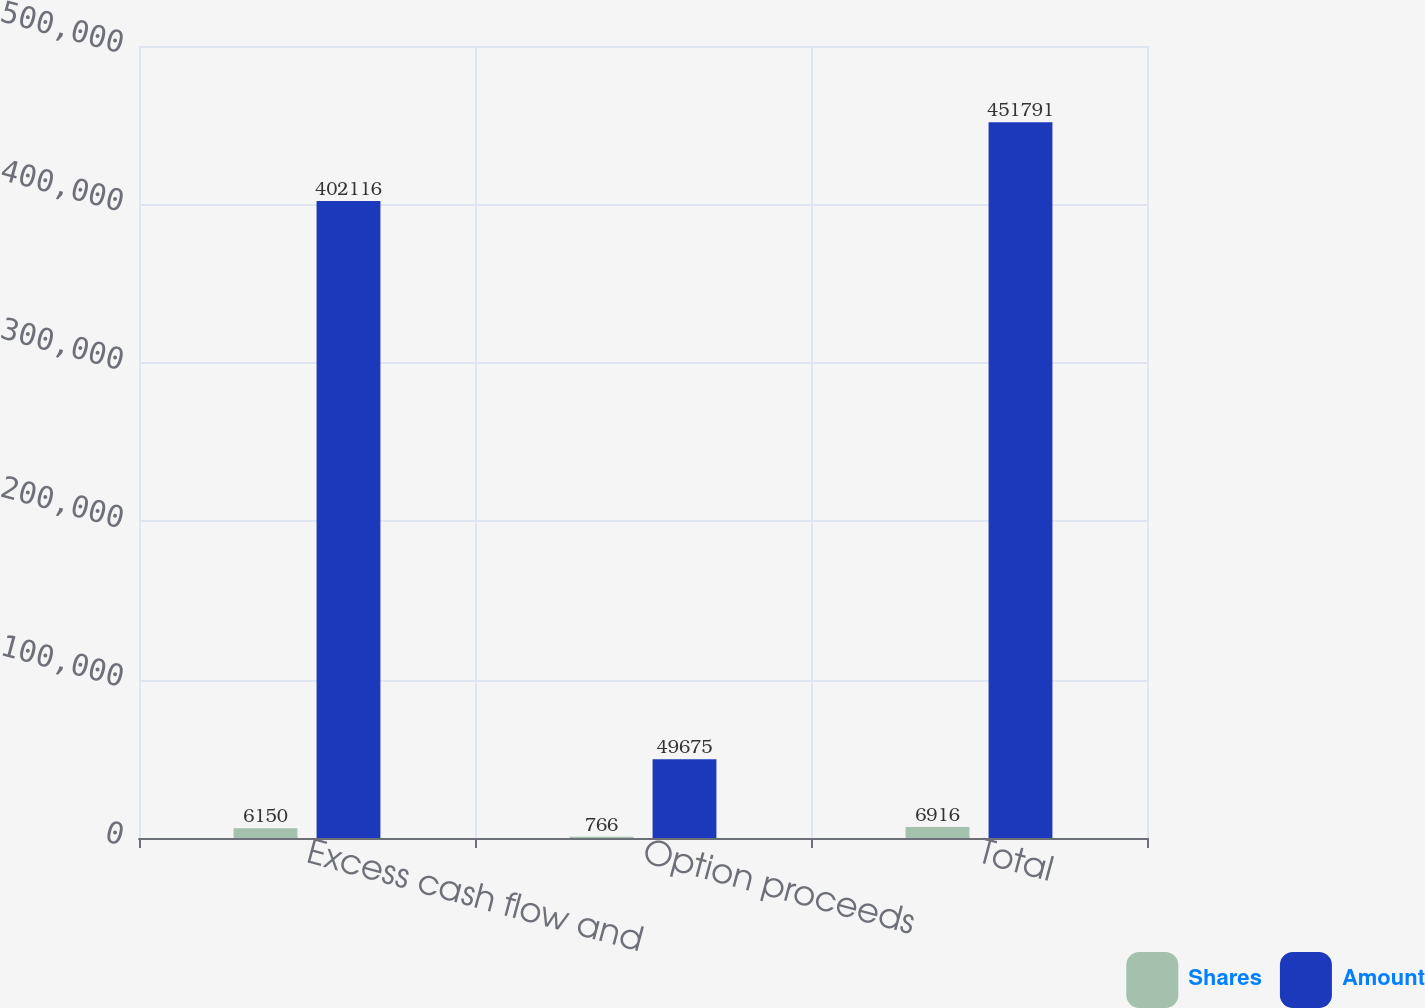Convert chart. <chart><loc_0><loc_0><loc_500><loc_500><stacked_bar_chart><ecel><fcel>Excess cash flow and<fcel>Option proceeds<fcel>Total<nl><fcel>Shares<fcel>6150<fcel>766<fcel>6916<nl><fcel>Amount<fcel>402116<fcel>49675<fcel>451791<nl></chart> 